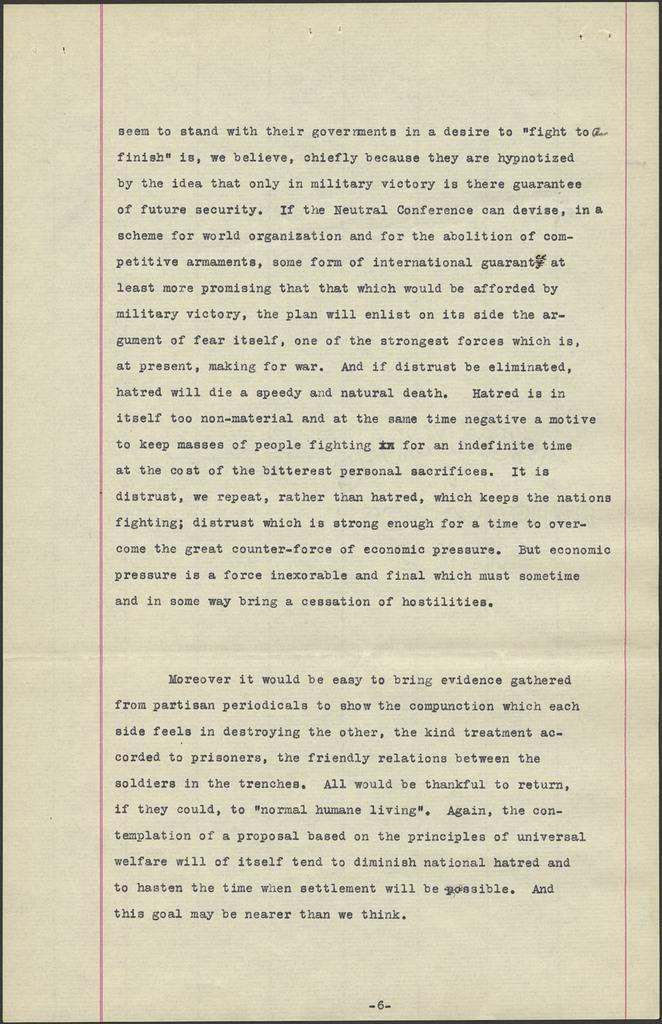Provide a one-sentence caption for the provided image. A piece of notebook paper with the first line stating "Seem to stand with their government in a desire...". 